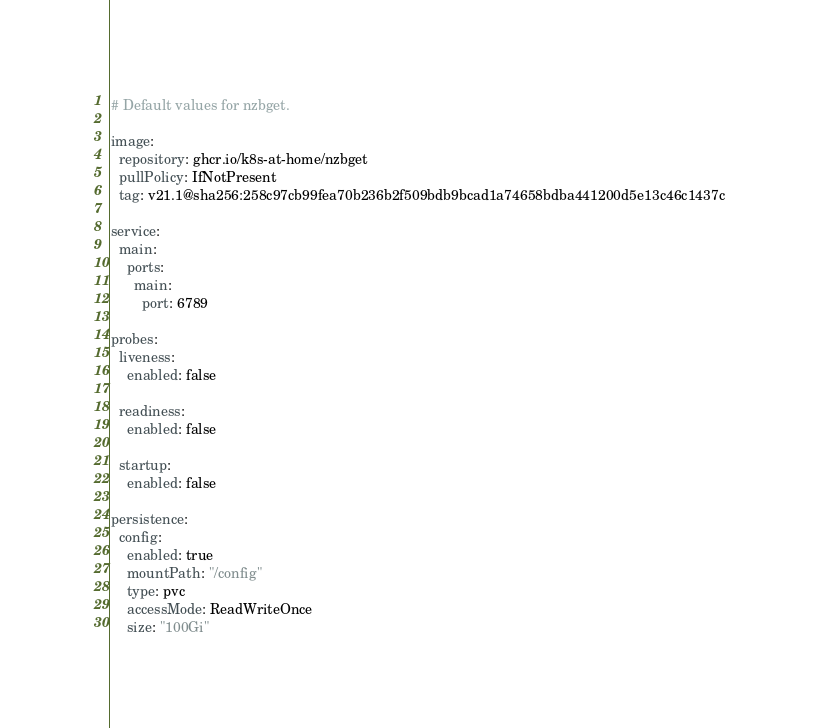Convert code to text. <code><loc_0><loc_0><loc_500><loc_500><_YAML_># Default values for nzbget.

image:
  repository: ghcr.io/k8s-at-home/nzbget
  pullPolicy: IfNotPresent
  tag: v21.1@sha256:258c97cb99fea70b236b2f509bdb9bcad1a74658bdba441200d5e13c46c1437c

service:
  main:
    ports:
      main:
        port: 6789

probes:
  liveness:
    enabled: false

  readiness:
    enabled: false

  startup:
    enabled: false

persistence:
  config:
    enabled: true
    mountPath: "/config"
    type: pvc
    accessMode: ReadWriteOnce
    size: "100Gi"
</code> 